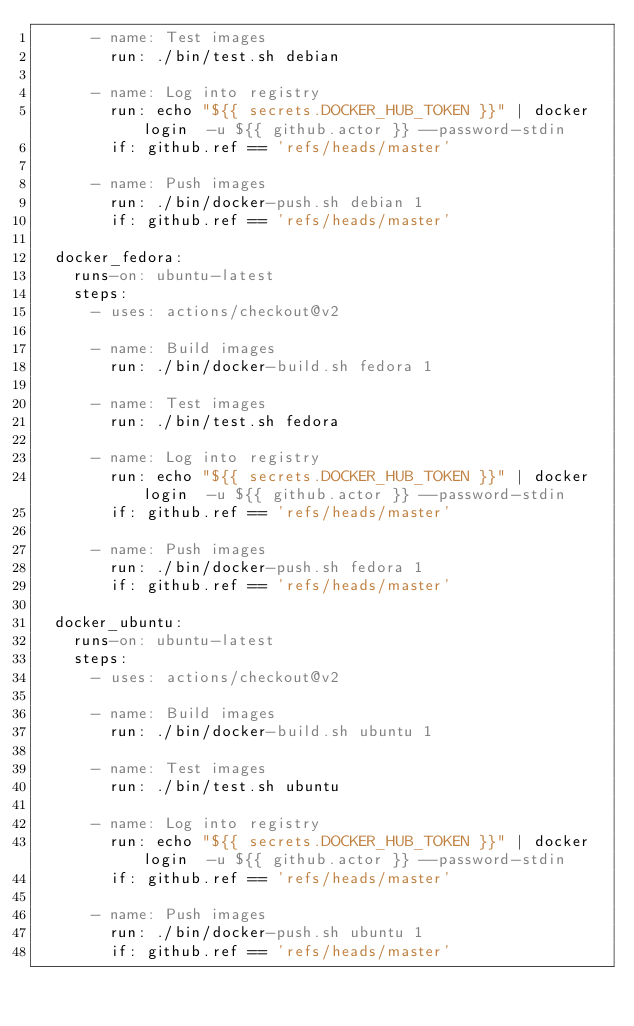Convert code to text. <code><loc_0><loc_0><loc_500><loc_500><_YAML_>      - name: Test images
        run: ./bin/test.sh debian

      - name: Log into registry
        run: echo "${{ secrets.DOCKER_HUB_TOKEN }}" | docker login  -u ${{ github.actor }} --password-stdin
        if: github.ref == 'refs/heads/master'

      - name: Push images
        run: ./bin/docker-push.sh debian 1
        if: github.ref == 'refs/heads/master'

  docker_fedora:
    runs-on: ubuntu-latest
    steps:
      - uses: actions/checkout@v2

      - name: Build images
        run: ./bin/docker-build.sh fedora 1

      - name: Test images
        run: ./bin/test.sh fedora

      - name: Log into registry
        run: echo "${{ secrets.DOCKER_HUB_TOKEN }}" | docker login  -u ${{ github.actor }} --password-stdin
        if: github.ref == 'refs/heads/master'

      - name: Push images
        run: ./bin/docker-push.sh fedora 1
        if: github.ref == 'refs/heads/master'

  docker_ubuntu:
    runs-on: ubuntu-latest
    steps:
      - uses: actions/checkout@v2

      - name: Build images
        run: ./bin/docker-build.sh ubuntu 1

      - name: Test images
        run: ./bin/test.sh ubuntu

      - name: Log into registry
        run: echo "${{ secrets.DOCKER_HUB_TOKEN }}" | docker login  -u ${{ github.actor }} --password-stdin
        if: github.ref == 'refs/heads/master'

      - name: Push images
        run: ./bin/docker-push.sh ubuntu 1
        if: github.ref == 'refs/heads/master'
</code> 